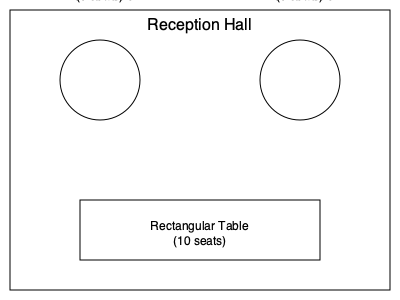Given the reception hall layout shown above, with two round tables seating 8 guests each and one rectangular table seating 10 guests, what is the maximum number of guests that can be seated if you need to leave one seat empty at each table for the bride to rotate between tables during the reception? To solve this problem, we need to follow these steps:

1. Calculate the available seats at each round table:
   - Each round table has 8 seats
   - We need to leave one seat empty
   - Available seats per round table = $8 - 1 = 7$

2. Calculate the total available seats for both round tables:
   - Total round table seats = $7 \times 2 = 14$

3. Calculate the available seats at the rectangular table:
   - The rectangular table has 10 seats
   - We need to leave one seat empty
   - Available seats at rectangular table = $10 - 1 = 9$

4. Sum up the total available seats:
   - Total available seats = Round table seats + Rectangular table seats
   - Total available seats = $14 + 9 = 23$

Therefore, the maximum number of guests that can be seated while leaving one seat empty at each table for the bride is 23.
Answer: 23 guests 